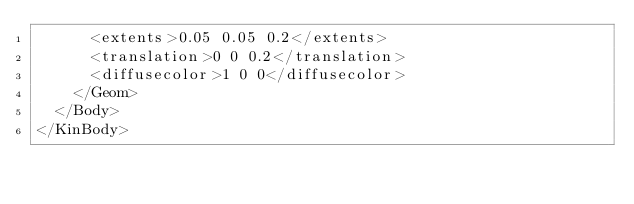<code> <loc_0><loc_0><loc_500><loc_500><_XML_>      <extents>0.05 0.05 0.2</extents>
      <translation>0 0 0.2</translation>
      <diffusecolor>1 0 0</diffusecolor>
    </Geom>
  </Body>
</KinBody>
</code> 